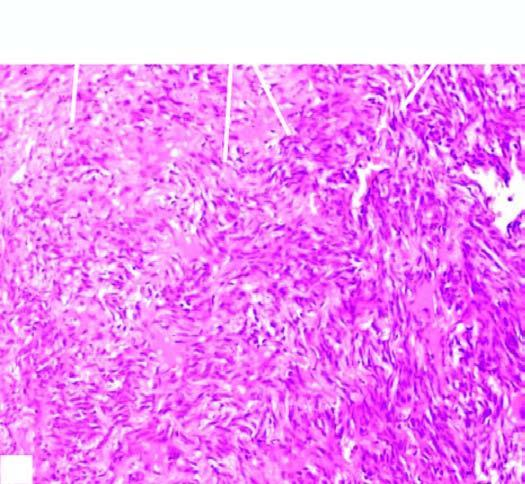what shows replacement of slaty-grey spongy parenchyma with multiple, firm, grey-white nodular masses, some having areas of haemorhages and necrosis?
Answer the question using a single word or phrase. Sectioned surface of the lung 